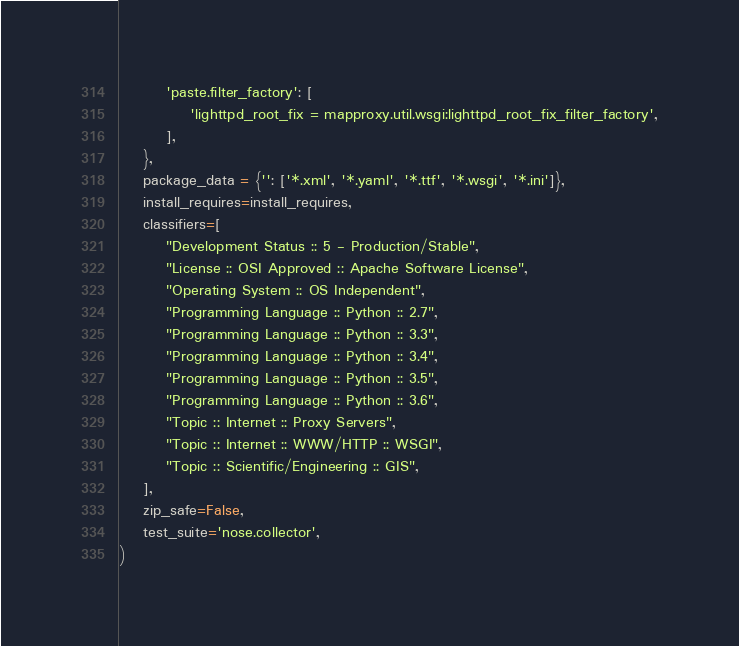<code> <loc_0><loc_0><loc_500><loc_500><_Python_>        'paste.filter_factory': [
            'lighttpd_root_fix = mapproxy.util.wsgi:lighttpd_root_fix_filter_factory',
        ],
    },
    package_data = {'': ['*.xml', '*.yaml', '*.ttf', '*.wsgi', '*.ini']},
    install_requires=install_requires,
    classifiers=[
        "Development Status :: 5 - Production/Stable",
        "License :: OSI Approved :: Apache Software License",
        "Operating System :: OS Independent",
        "Programming Language :: Python :: 2.7",
        "Programming Language :: Python :: 3.3",
        "Programming Language :: Python :: 3.4",
        "Programming Language :: Python :: 3.5",
        "Programming Language :: Python :: 3.6",
        "Topic :: Internet :: Proxy Servers",
        "Topic :: Internet :: WWW/HTTP :: WSGI",
        "Topic :: Scientific/Engineering :: GIS",
    ],
    zip_safe=False,
    test_suite='nose.collector',
)
</code> 